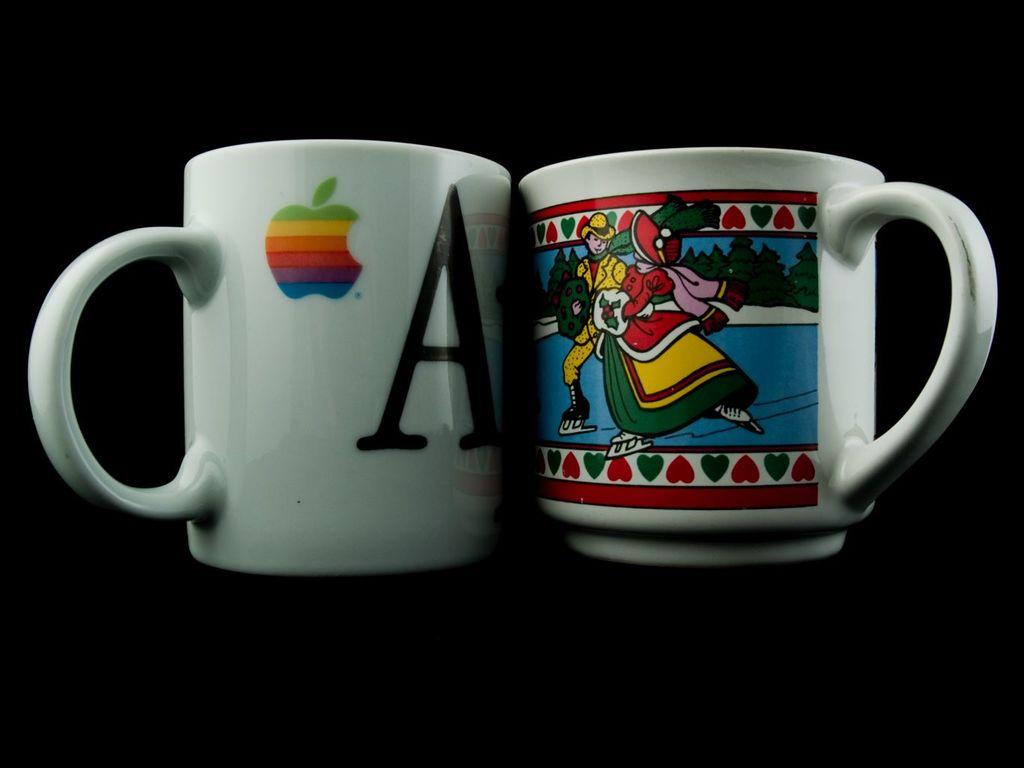What computer brand is the left mug?
Provide a succinct answer. Apple. 